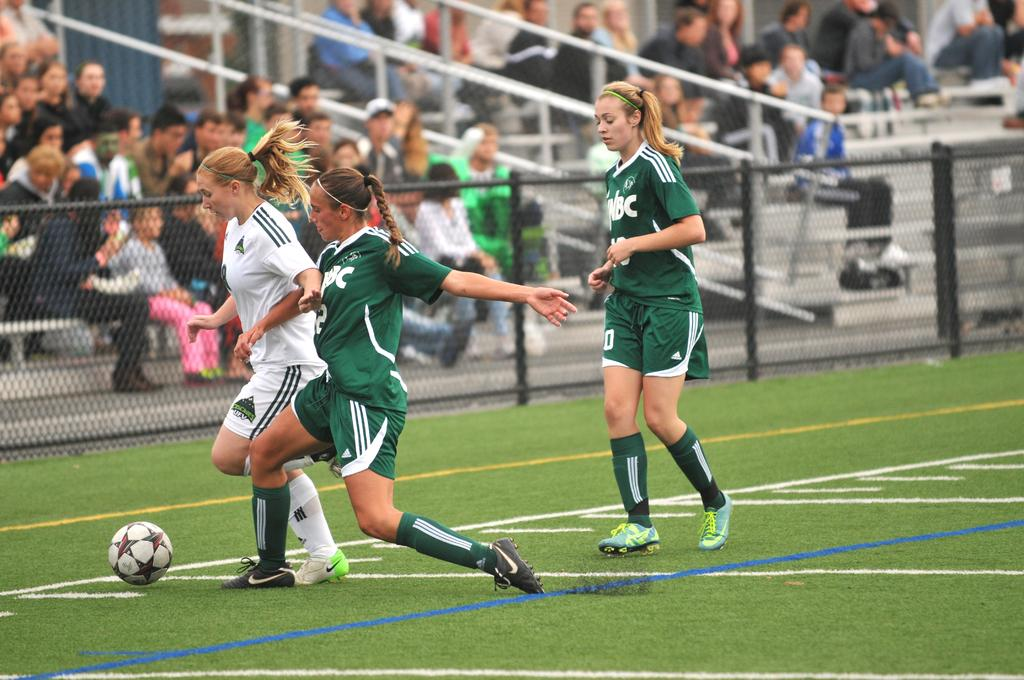How many people are in the image? There are people in the image, but the exact number is not specified. What are some of the people doing in the image? Some of the people are sitting, while others are playing in the ground. What can be seen in the background of the image? There is a fence and poles visible in the image. Can you describe the taste of the ocean in the image? There is no ocean present in the image, so it is not possible to describe its taste. 